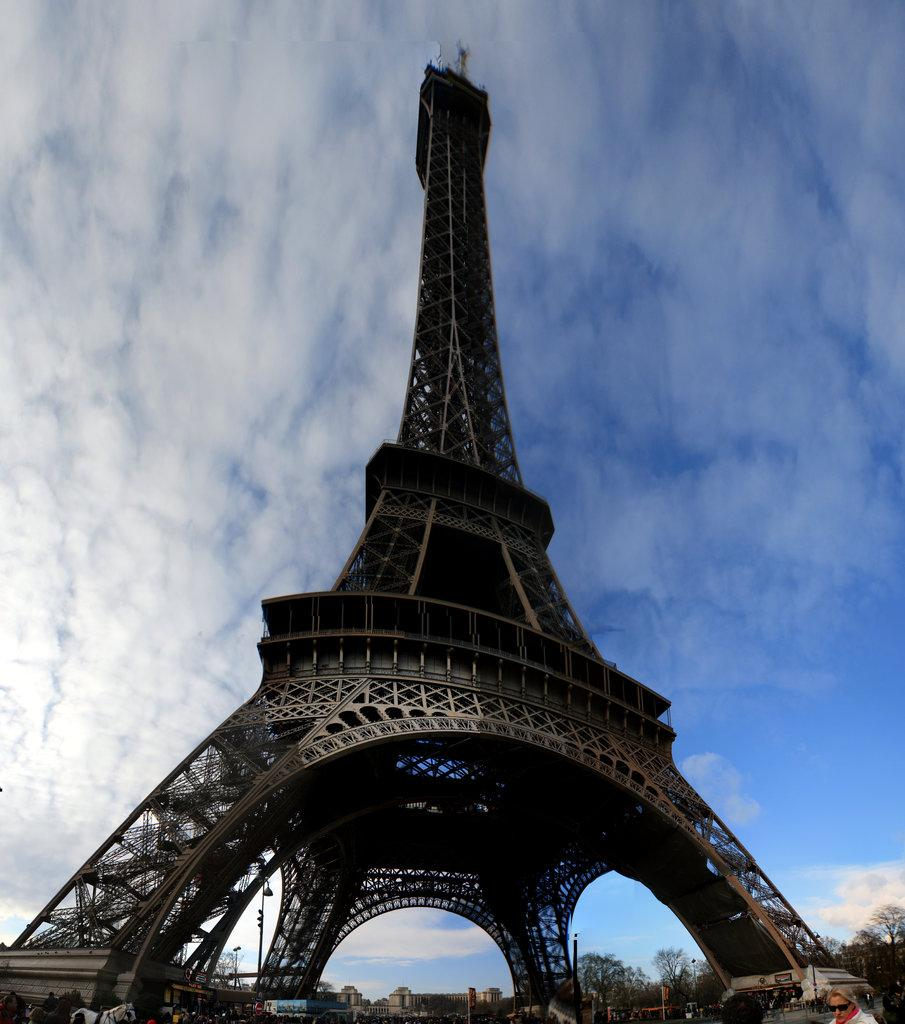What famous landmark can be seen in the image? The Eiffel Tower is visible in the image. What else is present in the image besides the Eiffel Tower? There are buildings, trees, poles, people, and an animal in the image. What is the sky like in the background of the image? The sky is visible in the background of the image, and there are clouds present. Can you tell me how many pictures are hanging on the walls in the image? There is no mention of pictures hanging on the walls in the image; the focus is on the Eiffel Tower, buildings, trees, poles, people, animal, and sky. 